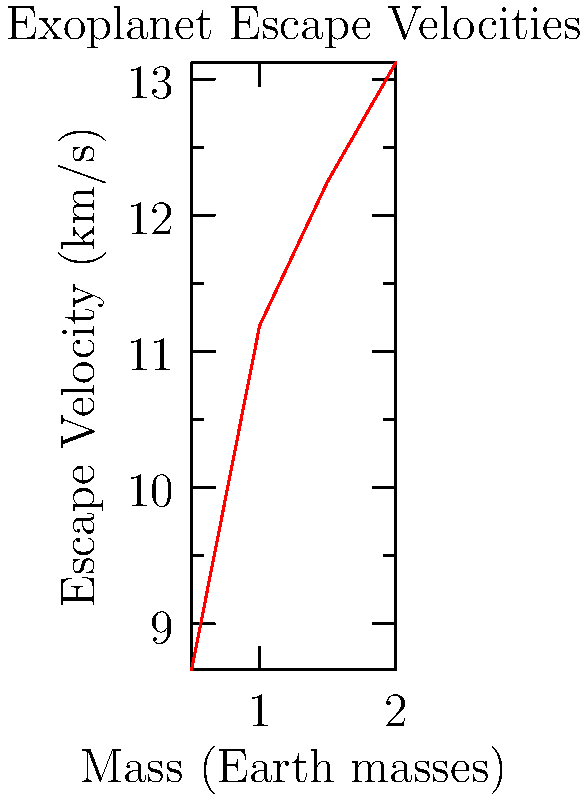Given the graph showing the relationship between mass and escape velocity for exoplanets, calculate the escape velocity for an exoplanet with a mass of 1.8 Earth masses and a radius of 1.3 Earth radii. Use the equation $v_e = \sqrt{\frac{2GM}{R}}$, where $G = 6.67 \times 10^{-11} \text{ m}^3 \text{kg}^{-1} \text{s}^{-2}$, $M$ is the mass of the exoplanet, and $R$ is its radius. To calculate the escape velocity, we'll use the equation $v_e = \sqrt{\frac{2GM}{R}}$. Let's break it down step-by-step:

1) First, we need to convert the given values to SI units:
   Mass: $M = 1.8 \times M_{\text{Earth}} = 1.8 \times 5.97 \times 10^{24} \text{ kg} = 1.0746 \times 10^{25} \text{ kg}$
   Radius: $R = 1.3 \times R_{\text{Earth}} = 1.3 \times 6.371 \times 10^6 \text{ m} = 8.2823 \times 10^6 \text{ m}$

2) Now, let's substitute these values into the equation:
   $$v_e = \sqrt{\frac{2 \times (6.67 \times 10^{-11}) \times (1.0746 \times 10^{25})}{8.2823 \times 10^6}}$$

3) Simplify under the square root:
   $$v_e = \sqrt{\frac{1.4335 \times 10^{15}}{8.2823 \times 10^6}} = \sqrt{1.7308 \times 10^8}$$

4) Calculate the final result:
   $$v_e = 13,155 \text{ m/s} = 13.16 \text{ km/s}$$

This result is consistent with the trend shown in the graph, where larger masses correspond to higher escape velocities.
Answer: 13.16 km/s 